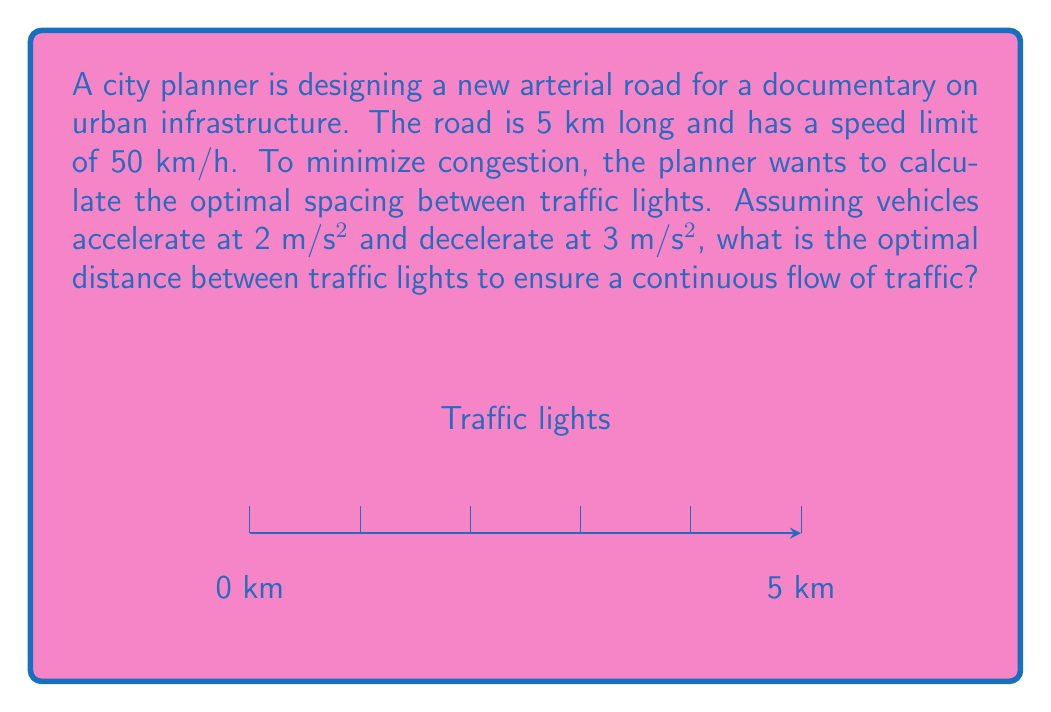What is the answer to this math problem? To solve this problem, we need to consider the time it takes for a vehicle to accelerate to the speed limit, travel at constant speed, and then decelerate to a stop. The optimal spacing will allow vehicles to reach the speed limit and maintain it for some distance before decelerating for the next light.

Step 1: Calculate the time to accelerate to the speed limit.
$v = v_0 + at$
$50 \text{ km/h} = 13.89 \text{ m/s} = 0 + 2t$
$t_a = 6.945 \text{ s}$

Step 2: Calculate the distance covered during acceleration.
$d_a = \frac{1}{2}at^2 = \frac{1}{2} \cdot 2 \cdot 6.945^2 = 48.23 \text{ m}$

Step 3: Calculate the time to decelerate from the speed limit to a stop.
$0 = 13.89 - 3t$
$t_d = 4.63 \text{ s}$

Step 4: Calculate the distance covered during deceleration.
$d_d = \frac{1}{2}at^2 = \frac{1}{2} \cdot 3 \cdot 4.63^2 = 32.15 \text{ m}$

Step 5: The optimal spacing should allow for acceleration, some constant speed travel, and deceleration. Let's call the distance at constant speed $d_c$.

$d_{total} = d_a + d_c + d_d$

Step 6: To ensure continuous flow, the time to cover this distance at the speed limit should equal the cycle time of the traffic light. Let's assume a standard cycle time of 90 seconds.

$\frac{d_{total}}{13.89 \text{ m/s}} = 90 \text{ s}$

$d_{total} = 13.89 \cdot 90 = 1250.1 \text{ m}$

Step 7: Calculate $d_c$.
$d_c = 1250.1 - 48.23 - 32.15 = 1169.72 \text{ m}$

Therefore, the optimal spacing between traffic lights is approximately 1250 meters or 1.25 km.
Answer: 1.25 km 